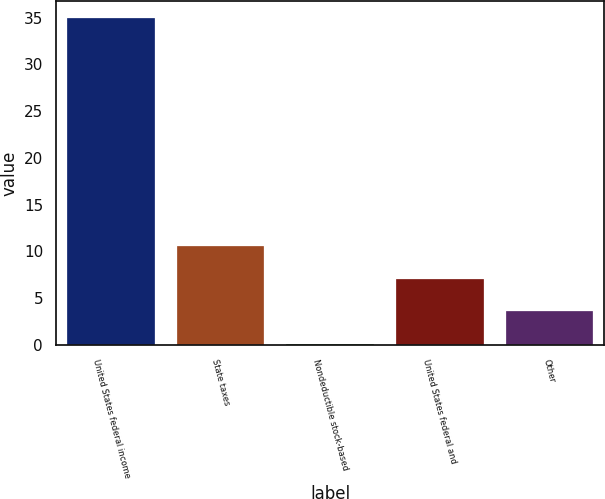Convert chart to OTSL. <chart><loc_0><loc_0><loc_500><loc_500><bar_chart><fcel>United States federal income<fcel>State taxes<fcel>Nondeductible stock-based<fcel>United States federal and<fcel>Other<nl><fcel>35<fcel>10.57<fcel>0.1<fcel>7.08<fcel>3.59<nl></chart> 